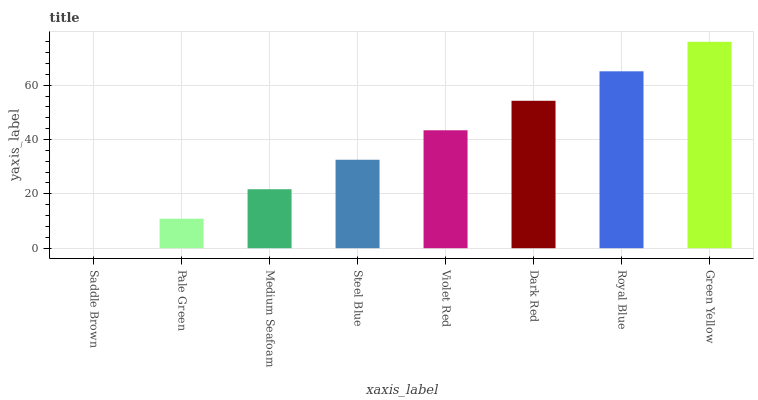Is Saddle Brown the minimum?
Answer yes or no. Yes. Is Green Yellow the maximum?
Answer yes or no. Yes. Is Pale Green the minimum?
Answer yes or no. No. Is Pale Green the maximum?
Answer yes or no. No. Is Pale Green greater than Saddle Brown?
Answer yes or no. Yes. Is Saddle Brown less than Pale Green?
Answer yes or no. Yes. Is Saddle Brown greater than Pale Green?
Answer yes or no. No. Is Pale Green less than Saddle Brown?
Answer yes or no. No. Is Violet Red the high median?
Answer yes or no. Yes. Is Steel Blue the low median?
Answer yes or no. Yes. Is Medium Seafoam the high median?
Answer yes or no. No. Is Saddle Brown the low median?
Answer yes or no. No. 